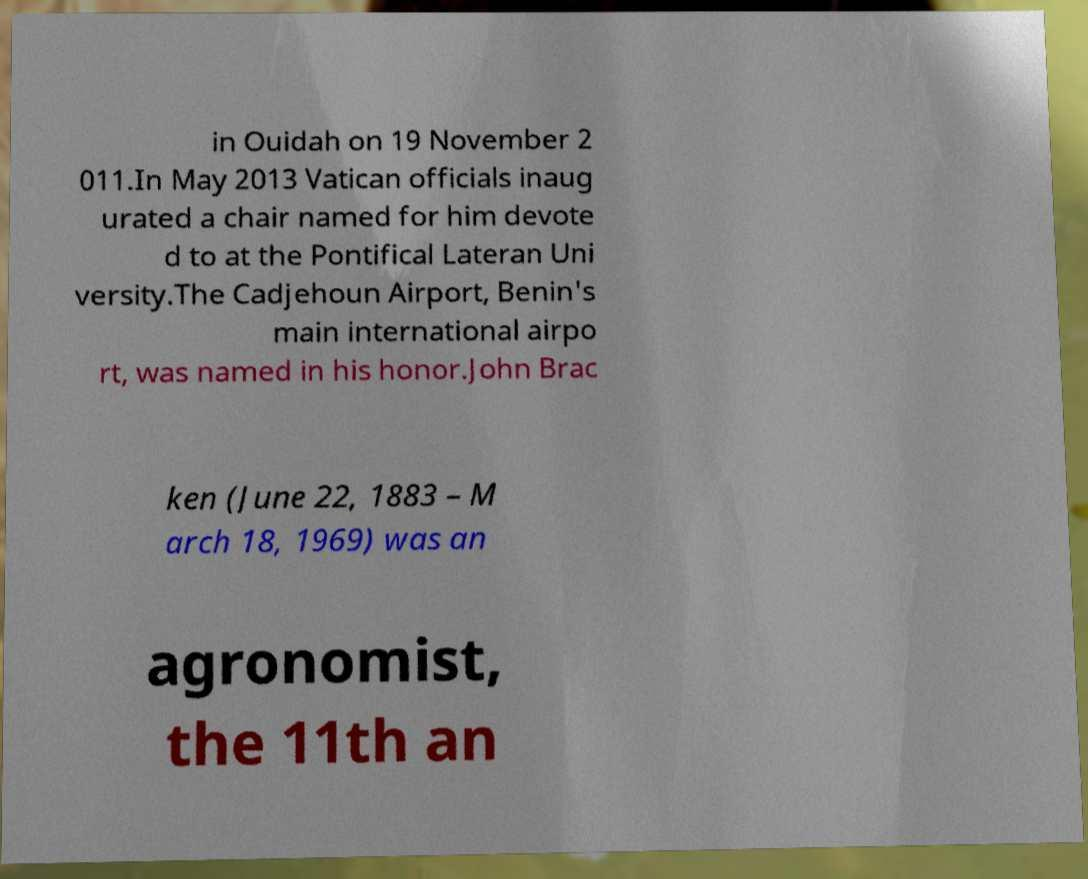There's text embedded in this image that I need extracted. Can you transcribe it verbatim? in Ouidah on 19 November 2 011.In May 2013 Vatican officials inaug urated a chair named for him devote d to at the Pontifical Lateran Uni versity.The Cadjehoun Airport, Benin's main international airpo rt, was named in his honor.John Brac ken (June 22, 1883 – M arch 18, 1969) was an agronomist, the 11th an 